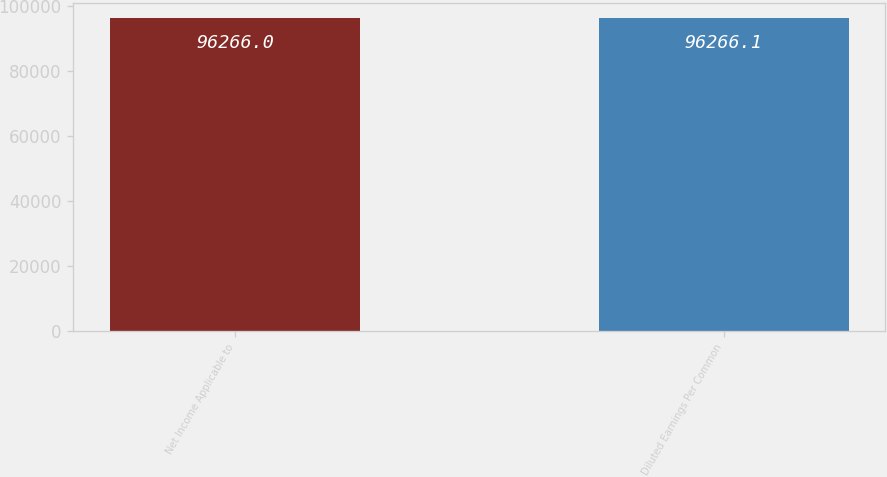<chart> <loc_0><loc_0><loc_500><loc_500><bar_chart><fcel>Net Income Applicable to<fcel>Diluted Earnings Per Common<nl><fcel>96266<fcel>96266.1<nl></chart> 